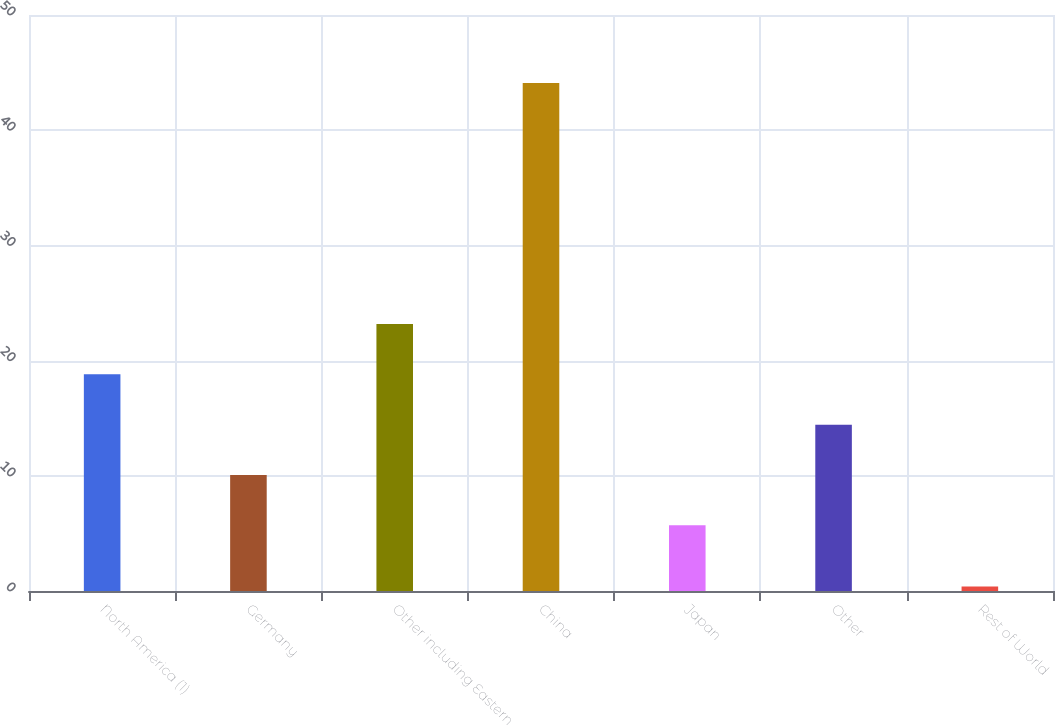Convert chart to OTSL. <chart><loc_0><loc_0><loc_500><loc_500><bar_chart><fcel>North America (1)<fcel>Germany<fcel>Other including Eastern<fcel>China<fcel>Japan<fcel>Other<fcel>Rest of World<nl><fcel>18.81<fcel>10.07<fcel>23.18<fcel>44.1<fcel>5.7<fcel>14.44<fcel>0.4<nl></chart> 